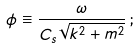Convert formula to latex. <formula><loc_0><loc_0><loc_500><loc_500>\phi \equiv \frac { \omega } { C _ { s } \sqrt { k ^ { 2 } + m ^ { 2 } } } \, ;</formula> 